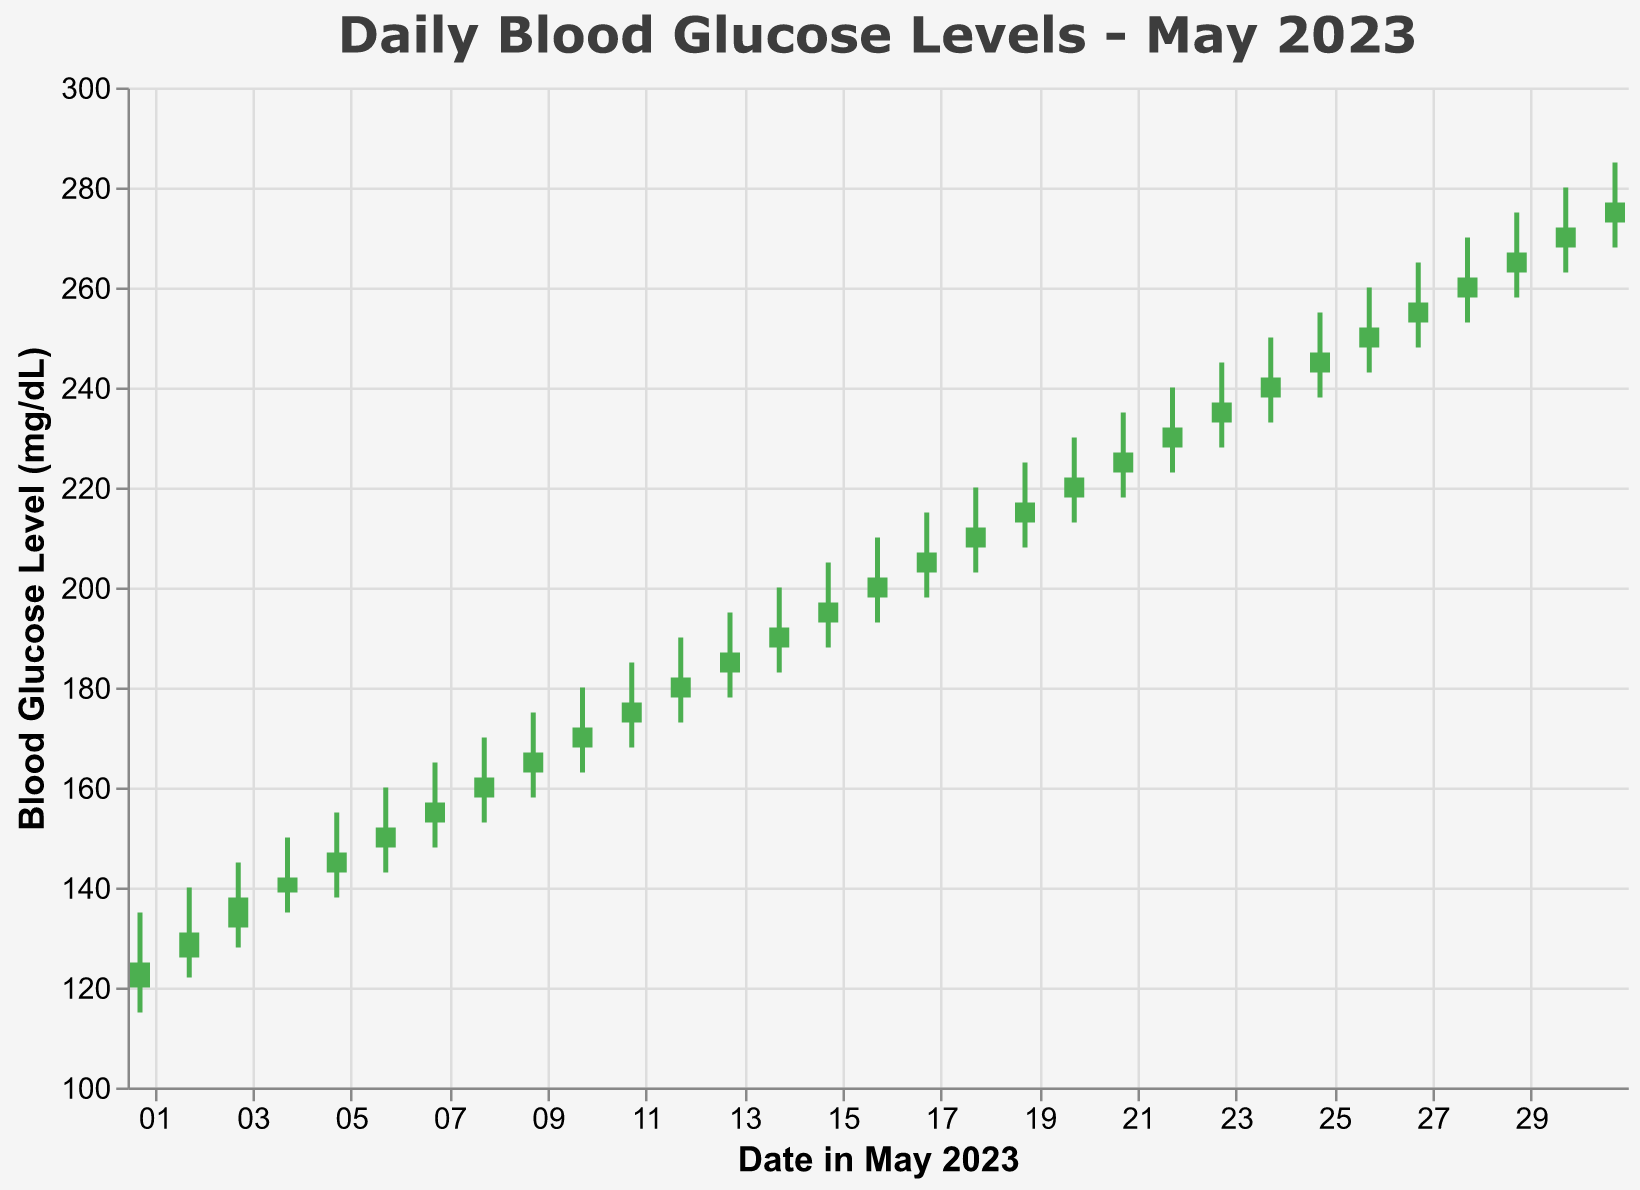What does the title of the chart indicate? The title "Daily Blood Glucose Levels - May 2023" indicates that the chart is showing the daily fluctuations of blood glucose levels over the month of May 2023.
Answer: It indicates daily blood glucose levels over May 2023 How many days of data are shown in the chart? Each day in May, from the 1st to the 31st, has been plotted on the chart. By counting, there are 31 days shown.
Answer: 31 days What were the highest and lowest blood glucose levels on May 15th? According to the chart, on May 15th the highest level was 205 mg/dL and the lowest was 188 mg/dL.
Answer: High: 205 mg/dL; Low: 188 mg/dL On May 7th, did the blood glucose level increase or decrease by the end of the day compared to the beginning? Open value for May 7th is 153 mg/dL, and the Close value is 157 mg/dL. Since 157 > 153, it increased by the end of the day.
Answer: It increased What is the average closing value for the first week in May? Sum of closing values from May 1st to May 7th (125+131+138+142+147+152+157) = 892. The average is 892/7 = 127.43.
Answer: 127.43 How does the blood glucose trend from May 1st to May 31st visually appear? The trend appears to be consistently increasing over the month, as the closing values rise steadily from May 1st to May 31st, with May 1st at 125 mg/dL and May 31st at 277 mg/dL.
Answer: Consistently increasing What is the difference between the highest blood glucose level on May 10th and May 20th? The highest level on May 10th is 180 mg/dL, and on May 20th is 230 mg/dL. The difference is 230 - 180 = 50 mg/dL.
Answer: 50 mg/dL Identify any period where the blood glucose levels were relatively stable. Between May 22nd and May 24th, the closing values of the blood glucose were 232, 237, and 242 mg/dL, which shows relatively small changes day-to-day.
Answer: May 22nd to May 24th Which date had the maximum fluctuation between high and low values, and what was that fluctuation? May 31st had High of 285 mg/dL and Low of 268 mg/dL; fluctuation is 285 - 268 = 17 mg/dL.
Answer: May 31st, 17 mg/dL Was there any day where the opening blood glucose level was equal to the closing level? No, the chart shows distinct Open and Close values for each day; none are equal.
Answer: No 